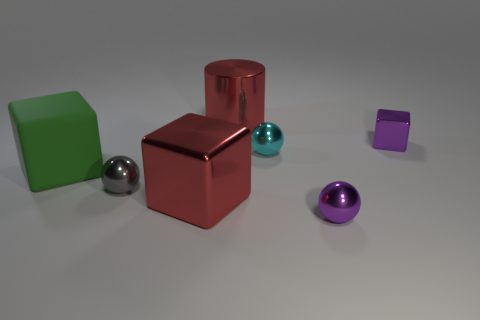Is there any other thing that is the same material as the green thing?
Give a very brief answer. No. Do the large object that is on the left side of the small gray thing and the large block that is right of the large green matte block have the same material?
Offer a terse response. No. How many cyan cylinders are there?
Your answer should be very brief. 0. How many large objects have the same shape as the small gray thing?
Ensure brevity in your answer.  0. Does the large rubber object have the same shape as the cyan shiny thing?
Your answer should be very brief. No. The gray shiny sphere is what size?
Provide a short and direct response. Small. How many red cubes have the same size as the green thing?
Give a very brief answer. 1. There is a red thing in front of the big rubber block; is it the same size as the shiny cube that is behind the big green thing?
Offer a terse response. No. There is a matte thing in front of the big red cylinder; what is its shape?
Your answer should be compact. Cube. What is the material of the block that is on the right side of the big red metal object in front of the big rubber thing?
Your response must be concise. Metal. 